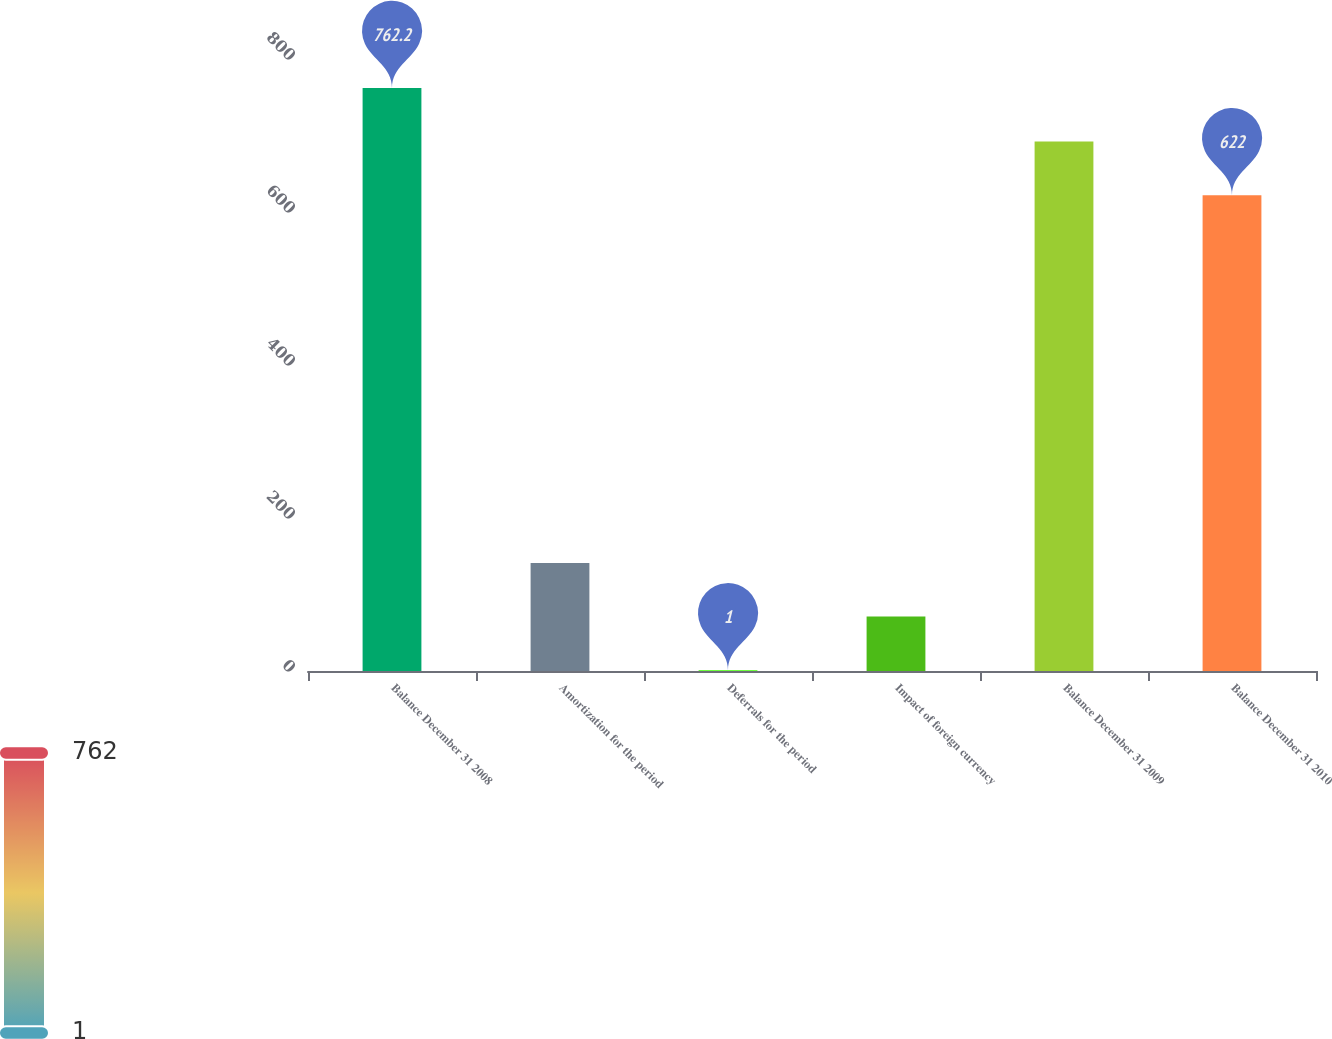<chart> <loc_0><loc_0><loc_500><loc_500><bar_chart><fcel>Balance December 31 2008<fcel>Amortization for the period<fcel>Deferrals for the period<fcel>Impact of foreign currency<fcel>Balance December 31 2009<fcel>Balance December 31 2010<nl><fcel>762.2<fcel>141.2<fcel>1<fcel>71.1<fcel>692.1<fcel>622<nl></chart> 